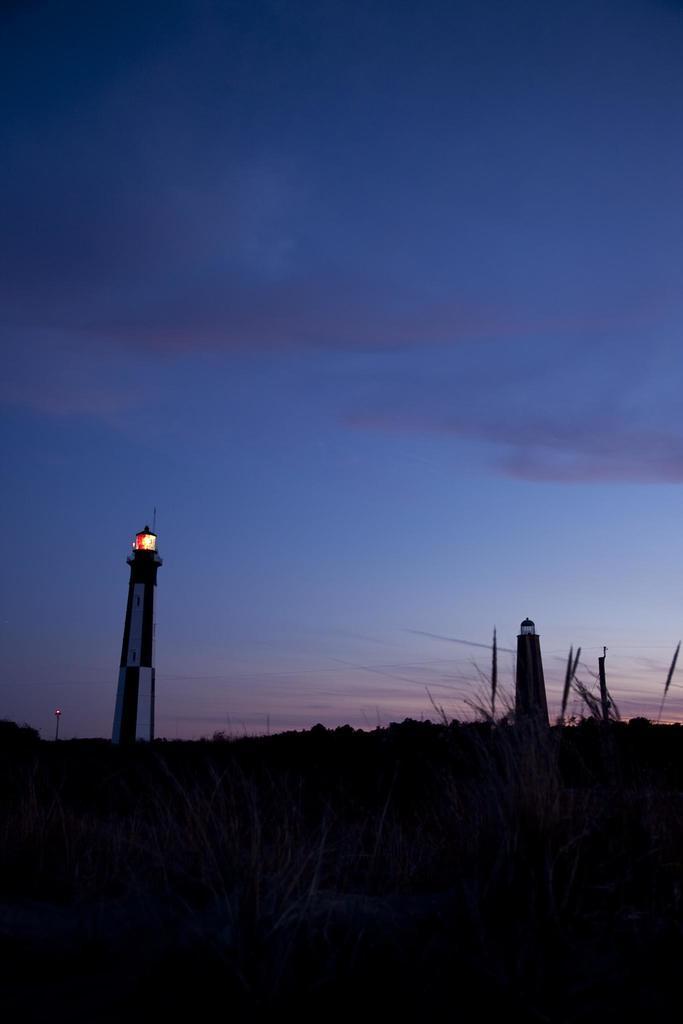Can you describe this image briefly? In this image, we can see a beautiful sky and there are lighthouses among them we can see light from one of the light house. 